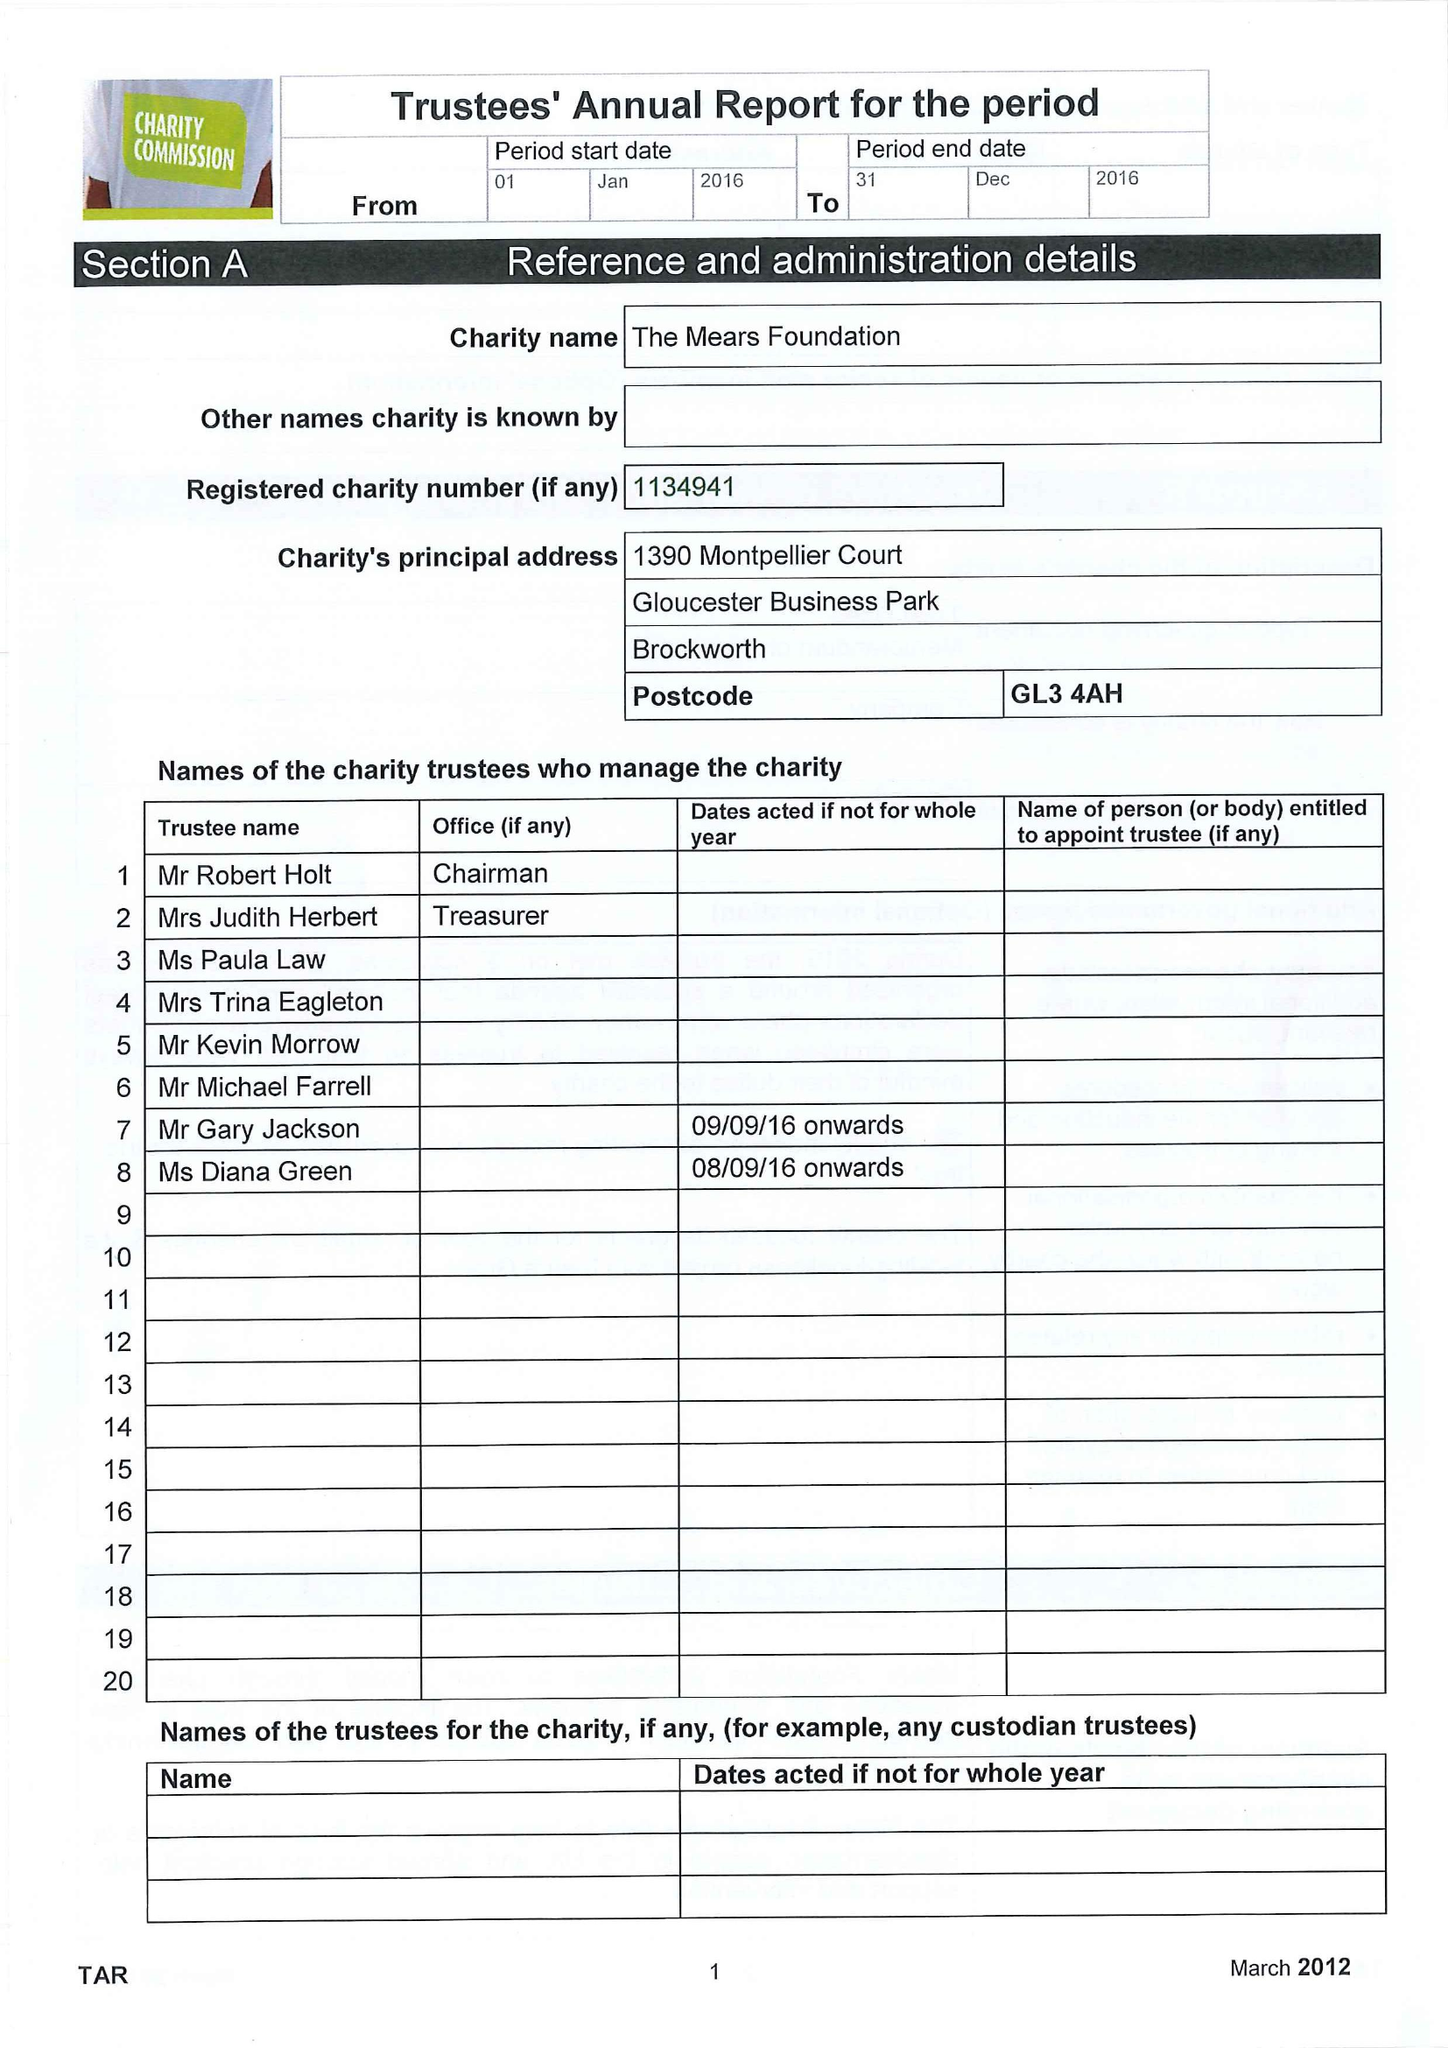What is the value for the charity_number?
Answer the question using a single word or phrase. 1134941 